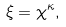<formula> <loc_0><loc_0><loc_500><loc_500>\xi = \chi ^ { \kappa } ,</formula> 